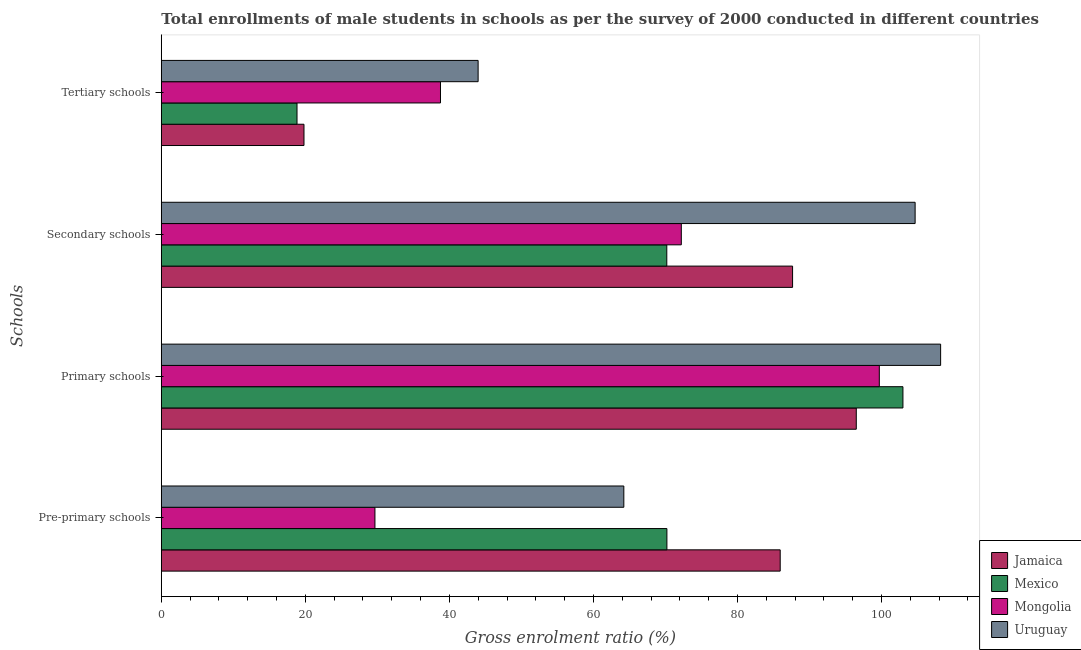How many different coloured bars are there?
Offer a very short reply. 4. How many groups of bars are there?
Provide a short and direct response. 4. Are the number of bars per tick equal to the number of legend labels?
Ensure brevity in your answer.  Yes. What is the label of the 2nd group of bars from the top?
Your answer should be very brief. Secondary schools. What is the gross enrolment ratio(male) in secondary schools in Jamaica?
Provide a succinct answer. 87.65. Across all countries, what is the maximum gross enrolment ratio(male) in pre-primary schools?
Give a very brief answer. 85.93. Across all countries, what is the minimum gross enrolment ratio(male) in tertiary schools?
Make the answer very short. 18.84. In which country was the gross enrolment ratio(male) in tertiary schools maximum?
Your answer should be compact. Uruguay. In which country was the gross enrolment ratio(male) in secondary schools minimum?
Offer a terse response. Mexico. What is the total gross enrolment ratio(male) in secondary schools in the graph?
Offer a terse response. 334.69. What is the difference between the gross enrolment ratio(male) in primary schools in Mexico and that in Mongolia?
Make the answer very short. 3.28. What is the difference between the gross enrolment ratio(male) in pre-primary schools in Mongolia and the gross enrolment ratio(male) in primary schools in Uruguay?
Provide a short and direct response. -78.54. What is the average gross enrolment ratio(male) in tertiary schools per country?
Your answer should be compact. 30.35. What is the difference between the gross enrolment ratio(male) in pre-primary schools and gross enrolment ratio(male) in secondary schools in Mexico?
Your answer should be compact. 0.01. What is the ratio of the gross enrolment ratio(male) in tertiary schools in Mexico to that in Uruguay?
Provide a succinct answer. 0.43. Is the difference between the gross enrolment ratio(male) in primary schools in Mongolia and Uruguay greater than the difference between the gross enrolment ratio(male) in tertiary schools in Mongolia and Uruguay?
Ensure brevity in your answer.  No. What is the difference between the highest and the second highest gross enrolment ratio(male) in tertiary schools?
Ensure brevity in your answer.  5.23. What is the difference between the highest and the lowest gross enrolment ratio(male) in pre-primary schools?
Make the answer very short. 56.27. In how many countries, is the gross enrolment ratio(male) in primary schools greater than the average gross enrolment ratio(male) in primary schools taken over all countries?
Provide a short and direct response. 2. What does the 1st bar from the top in Tertiary schools represents?
Your answer should be very brief. Uruguay. What does the 4th bar from the bottom in Pre-primary schools represents?
Your answer should be very brief. Uruguay. How many bars are there?
Your answer should be very brief. 16. What is the difference between two consecutive major ticks on the X-axis?
Provide a short and direct response. 20. Does the graph contain any zero values?
Offer a very short reply. No. Does the graph contain grids?
Provide a succinct answer. No. Where does the legend appear in the graph?
Your answer should be very brief. Bottom right. How many legend labels are there?
Keep it short and to the point. 4. How are the legend labels stacked?
Your answer should be very brief. Vertical. What is the title of the graph?
Your answer should be compact. Total enrollments of male students in schools as per the survey of 2000 conducted in different countries. Does "New Caledonia" appear as one of the legend labels in the graph?
Your response must be concise. No. What is the label or title of the X-axis?
Provide a succinct answer. Gross enrolment ratio (%). What is the label or title of the Y-axis?
Offer a terse response. Schools. What is the Gross enrolment ratio (%) of Jamaica in Pre-primary schools?
Your response must be concise. 85.93. What is the Gross enrolment ratio (%) in Mexico in Pre-primary schools?
Your answer should be very brief. 70.2. What is the Gross enrolment ratio (%) in Mongolia in Pre-primary schools?
Your response must be concise. 29.66. What is the Gross enrolment ratio (%) of Uruguay in Pre-primary schools?
Your answer should be very brief. 64.22. What is the Gross enrolment ratio (%) in Jamaica in Primary schools?
Your response must be concise. 96.49. What is the Gross enrolment ratio (%) in Mexico in Primary schools?
Give a very brief answer. 102.97. What is the Gross enrolment ratio (%) in Mongolia in Primary schools?
Offer a terse response. 99.69. What is the Gross enrolment ratio (%) of Uruguay in Primary schools?
Keep it short and to the point. 108.2. What is the Gross enrolment ratio (%) of Jamaica in Secondary schools?
Ensure brevity in your answer.  87.65. What is the Gross enrolment ratio (%) in Mexico in Secondary schools?
Ensure brevity in your answer.  70.18. What is the Gross enrolment ratio (%) in Mongolia in Secondary schools?
Ensure brevity in your answer.  72.2. What is the Gross enrolment ratio (%) of Uruguay in Secondary schools?
Ensure brevity in your answer.  104.66. What is the Gross enrolment ratio (%) of Jamaica in Tertiary schools?
Give a very brief answer. 19.81. What is the Gross enrolment ratio (%) in Mexico in Tertiary schools?
Ensure brevity in your answer.  18.84. What is the Gross enrolment ratio (%) of Mongolia in Tertiary schools?
Provide a succinct answer. 38.76. What is the Gross enrolment ratio (%) in Uruguay in Tertiary schools?
Ensure brevity in your answer.  43.99. Across all Schools, what is the maximum Gross enrolment ratio (%) of Jamaica?
Keep it short and to the point. 96.49. Across all Schools, what is the maximum Gross enrolment ratio (%) in Mexico?
Your answer should be compact. 102.97. Across all Schools, what is the maximum Gross enrolment ratio (%) in Mongolia?
Your answer should be very brief. 99.69. Across all Schools, what is the maximum Gross enrolment ratio (%) of Uruguay?
Offer a very short reply. 108.2. Across all Schools, what is the minimum Gross enrolment ratio (%) of Jamaica?
Keep it short and to the point. 19.81. Across all Schools, what is the minimum Gross enrolment ratio (%) of Mexico?
Make the answer very short. 18.84. Across all Schools, what is the minimum Gross enrolment ratio (%) of Mongolia?
Offer a terse response. 29.66. Across all Schools, what is the minimum Gross enrolment ratio (%) in Uruguay?
Offer a terse response. 43.99. What is the total Gross enrolment ratio (%) of Jamaica in the graph?
Your response must be concise. 289.88. What is the total Gross enrolment ratio (%) in Mexico in the graph?
Give a very brief answer. 262.19. What is the total Gross enrolment ratio (%) of Mongolia in the graph?
Your response must be concise. 240.31. What is the total Gross enrolment ratio (%) of Uruguay in the graph?
Offer a terse response. 321.07. What is the difference between the Gross enrolment ratio (%) of Jamaica in Pre-primary schools and that in Primary schools?
Your response must be concise. -10.56. What is the difference between the Gross enrolment ratio (%) in Mexico in Pre-primary schools and that in Primary schools?
Provide a succinct answer. -32.77. What is the difference between the Gross enrolment ratio (%) of Mongolia in Pre-primary schools and that in Primary schools?
Ensure brevity in your answer.  -70.03. What is the difference between the Gross enrolment ratio (%) in Uruguay in Pre-primary schools and that in Primary schools?
Your answer should be compact. -43.98. What is the difference between the Gross enrolment ratio (%) of Jamaica in Pre-primary schools and that in Secondary schools?
Keep it short and to the point. -1.72. What is the difference between the Gross enrolment ratio (%) of Mexico in Pre-primary schools and that in Secondary schools?
Keep it short and to the point. 0.01. What is the difference between the Gross enrolment ratio (%) of Mongolia in Pre-primary schools and that in Secondary schools?
Provide a succinct answer. -42.54. What is the difference between the Gross enrolment ratio (%) of Uruguay in Pre-primary schools and that in Secondary schools?
Your answer should be compact. -40.45. What is the difference between the Gross enrolment ratio (%) in Jamaica in Pre-primary schools and that in Tertiary schools?
Ensure brevity in your answer.  66.12. What is the difference between the Gross enrolment ratio (%) in Mexico in Pre-primary schools and that in Tertiary schools?
Ensure brevity in your answer.  51.36. What is the difference between the Gross enrolment ratio (%) of Mongolia in Pre-primary schools and that in Tertiary schools?
Give a very brief answer. -9.1. What is the difference between the Gross enrolment ratio (%) of Uruguay in Pre-primary schools and that in Tertiary schools?
Your answer should be compact. 20.23. What is the difference between the Gross enrolment ratio (%) in Jamaica in Primary schools and that in Secondary schools?
Your response must be concise. 8.85. What is the difference between the Gross enrolment ratio (%) in Mexico in Primary schools and that in Secondary schools?
Provide a short and direct response. 32.79. What is the difference between the Gross enrolment ratio (%) of Mongolia in Primary schools and that in Secondary schools?
Give a very brief answer. 27.49. What is the difference between the Gross enrolment ratio (%) in Uruguay in Primary schools and that in Secondary schools?
Your answer should be compact. 3.54. What is the difference between the Gross enrolment ratio (%) of Jamaica in Primary schools and that in Tertiary schools?
Offer a terse response. 76.68. What is the difference between the Gross enrolment ratio (%) in Mexico in Primary schools and that in Tertiary schools?
Ensure brevity in your answer.  84.13. What is the difference between the Gross enrolment ratio (%) in Mongolia in Primary schools and that in Tertiary schools?
Offer a very short reply. 60.93. What is the difference between the Gross enrolment ratio (%) of Uruguay in Primary schools and that in Tertiary schools?
Your response must be concise. 64.22. What is the difference between the Gross enrolment ratio (%) of Jamaica in Secondary schools and that in Tertiary schools?
Make the answer very short. 67.84. What is the difference between the Gross enrolment ratio (%) in Mexico in Secondary schools and that in Tertiary schools?
Offer a very short reply. 51.34. What is the difference between the Gross enrolment ratio (%) in Mongolia in Secondary schools and that in Tertiary schools?
Your answer should be compact. 33.44. What is the difference between the Gross enrolment ratio (%) of Uruguay in Secondary schools and that in Tertiary schools?
Your answer should be compact. 60.68. What is the difference between the Gross enrolment ratio (%) of Jamaica in Pre-primary schools and the Gross enrolment ratio (%) of Mexico in Primary schools?
Offer a terse response. -17.04. What is the difference between the Gross enrolment ratio (%) in Jamaica in Pre-primary schools and the Gross enrolment ratio (%) in Mongolia in Primary schools?
Provide a short and direct response. -13.76. What is the difference between the Gross enrolment ratio (%) in Jamaica in Pre-primary schools and the Gross enrolment ratio (%) in Uruguay in Primary schools?
Keep it short and to the point. -22.27. What is the difference between the Gross enrolment ratio (%) of Mexico in Pre-primary schools and the Gross enrolment ratio (%) of Mongolia in Primary schools?
Your answer should be compact. -29.49. What is the difference between the Gross enrolment ratio (%) of Mexico in Pre-primary schools and the Gross enrolment ratio (%) of Uruguay in Primary schools?
Give a very brief answer. -38. What is the difference between the Gross enrolment ratio (%) of Mongolia in Pre-primary schools and the Gross enrolment ratio (%) of Uruguay in Primary schools?
Provide a succinct answer. -78.54. What is the difference between the Gross enrolment ratio (%) of Jamaica in Pre-primary schools and the Gross enrolment ratio (%) of Mexico in Secondary schools?
Make the answer very short. 15.75. What is the difference between the Gross enrolment ratio (%) of Jamaica in Pre-primary schools and the Gross enrolment ratio (%) of Mongolia in Secondary schools?
Ensure brevity in your answer.  13.73. What is the difference between the Gross enrolment ratio (%) in Jamaica in Pre-primary schools and the Gross enrolment ratio (%) in Uruguay in Secondary schools?
Your response must be concise. -18.73. What is the difference between the Gross enrolment ratio (%) in Mexico in Pre-primary schools and the Gross enrolment ratio (%) in Mongolia in Secondary schools?
Give a very brief answer. -2. What is the difference between the Gross enrolment ratio (%) in Mexico in Pre-primary schools and the Gross enrolment ratio (%) in Uruguay in Secondary schools?
Provide a succinct answer. -34.46. What is the difference between the Gross enrolment ratio (%) of Mongolia in Pre-primary schools and the Gross enrolment ratio (%) of Uruguay in Secondary schools?
Offer a terse response. -75. What is the difference between the Gross enrolment ratio (%) of Jamaica in Pre-primary schools and the Gross enrolment ratio (%) of Mexico in Tertiary schools?
Your answer should be very brief. 67.09. What is the difference between the Gross enrolment ratio (%) in Jamaica in Pre-primary schools and the Gross enrolment ratio (%) in Mongolia in Tertiary schools?
Provide a succinct answer. 47.17. What is the difference between the Gross enrolment ratio (%) of Jamaica in Pre-primary schools and the Gross enrolment ratio (%) of Uruguay in Tertiary schools?
Give a very brief answer. 41.94. What is the difference between the Gross enrolment ratio (%) in Mexico in Pre-primary schools and the Gross enrolment ratio (%) in Mongolia in Tertiary schools?
Keep it short and to the point. 31.44. What is the difference between the Gross enrolment ratio (%) of Mexico in Pre-primary schools and the Gross enrolment ratio (%) of Uruguay in Tertiary schools?
Your answer should be very brief. 26.21. What is the difference between the Gross enrolment ratio (%) of Mongolia in Pre-primary schools and the Gross enrolment ratio (%) of Uruguay in Tertiary schools?
Provide a short and direct response. -14.33. What is the difference between the Gross enrolment ratio (%) in Jamaica in Primary schools and the Gross enrolment ratio (%) in Mexico in Secondary schools?
Make the answer very short. 26.31. What is the difference between the Gross enrolment ratio (%) in Jamaica in Primary schools and the Gross enrolment ratio (%) in Mongolia in Secondary schools?
Provide a succinct answer. 24.29. What is the difference between the Gross enrolment ratio (%) in Jamaica in Primary schools and the Gross enrolment ratio (%) in Uruguay in Secondary schools?
Provide a succinct answer. -8.17. What is the difference between the Gross enrolment ratio (%) in Mexico in Primary schools and the Gross enrolment ratio (%) in Mongolia in Secondary schools?
Give a very brief answer. 30.77. What is the difference between the Gross enrolment ratio (%) of Mexico in Primary schools and the Gross enrolment ratio (%) of Uruguay in Secondary schools?
Give a very brief answer. -1.69. What is the difference between the Gross enrolment ratio (%) of Mongolia in Primary schools and the Gross enrolment ratio (%) of Uruguay in Secondary schools?
Keep it short and to the point. -4.97. What is the difference between the Gross enrolment ratio (%) of Jamaica in Primary schools and the Gross enrolment ratio (%) of Mexico in Tertiary schools?
Make the answer very short. 77.65. What is the difference between the Gross enrolment ratio (%) of Jamaica in Primary schools and the Gross enrolment ratio (%) of Mongolia in Tertiary schools?
Your response must be concise. 57.73. What is the difference between the Gross enrolment ratio (%) of Jamaica in Primary schools and the Gross enrolment ratio (%) of Uruguay in Tertiary schools?
Offer a very short reply. 52.51. What is the difference between the Gross enrolment ratio (%) of Mexico in Primary schools and the Gross enrolment ratio (%) of Mongolia in Tertiary schools?
Ensure brevity in your answer.  64.21. What is the difference between the Gross enrolment ratio (%) in Mexico in Primary schools and the Gross enrolment ratio (%) in Uruguay in Tertiary schools?
Keep it short and to the point. 58.98. What is the difference between the Gross enrolment ratio (%) in Mongolia in Primary schools and the Gross enrolment ratio (%) in Uruguay in Tertiary schools?
Give a very brief answer. 55.7. What is the difference between the Gross enrolment ratio (%) of Jamaica in Secondary schools and the Gross enrolment ratio (%) of Mexico in Tertiary schools?
Provide a succinct answer. 68.81. What is the difference between the Gross enrolment ratio (%) of Jamaica in Secondary schools and the Gross enrolment ratio (%) of Mongolia in Tertiary schools?
Offer a very short reply. 48.89. What is the difference between the Gross enrolment ratio (%) of Jamaica in Secondary schools and the Gross enrolment ratio (%) of Uruguay in Tertiary schools?
Your response must be concise. 43.66. What is the difference between the Gross enrolment ratio (%) in Mexico in Secondary schools and the Gross enrolment ratio (%) in Mongolia in Tertiary schools?
Make the answer very short. 31.42. What is the difference between the Gross enrolment ratio (%) in Mexico in Secondary schools and the Gross enrolment ratio (%) in Uruguay in Tertiary schools?
Provide a short and direct response. 26.2. What is the difference between the Gross enrolment ratio (%) of Mongolia in Secondary schools and the Gross enrolment ratio (%) of Uruguay in Tertiary schools?
Provide a short and direct response. 28.21. What is the average Gross enrolment ratio (%) of Jamaica per Schools?
Make the answer very short. 72.47. What is the average Gross enrolment ratio (%) of Mexico per Schools?
Offer a very short reply. 65.55. What is the average Gross enrolment ratio (%) of Mongolia per Schools?
Keep it short and to the point. 60.08. What is the average Gross enrolment ratio (%) in Uruguay per Schools?
Keep it short and to the point. 80.27. What is the difference between the Gross enrolment ratio (%) in Jamaica and Gross enrolment ratio (%) in Mexico in Pre-primary schools?
Provide a succinct answer. 15.73. What is the difference between the Gross enrolment ratio (%) of Jamaica and Gross enrolment ratio (%) of Mongolia in Pre-primary schools?
Keep it short and to the point. 56.27. What is the difference between the Gross enrolment ratio (%) of Jamaica and Gross enrolment ratio (%) of Uruguay in Pre-primary schools?
Keep it short and to the point. 21.71. What is the difference between the Gross enrolment ratio (%) in Mexico and Gross enrolment ratio (%) in Mongolia in Pre-primary schools?
Provide a short and direct response. 40.54. What is the difference between the Gross enrolment ratio (%) of Mexico and Gross enrolment ratio (%) of Uruguay in Pre-primary schools?
Your response must be concise. 5.98. What is the difference between the Gross enrolment ratio (%) of Mongolia and Gross enrolment ratio (%) of Uruguay in Pre-primary schools?
Provide a succinct answer. -34.56. What is the difference between the Gross enrolment ratio (%) in Jamaica and Gross enrolment ratio (%) in Mexico in Primary schools?
Keep it short and to the point. -6.48. What is the difference between the Gross enrolment ratio (%) of Jamaica and Gross enrolment ratio (%) of Mongolia in Primary schools?
Your answer should be compact. -3.2. What is the difference between the Gross enrolment ratio (%) in Jamaica and Gross enrolment ratio (%) in Uruguay in Primary schools?
Your response must be concise. -11.71. What is the difference between the Gross enrolment ratio (%) of Mexico and Gross enrolment ratio (%) of Mongolia in Primary schools?
Your response must be concise. 3.28. What is the difference between the Gross enrolment ratio (%) in Mexico and Gross enrolment ratio (%) in Uruguay in Primary schools?
Your answer should be very brief. -5.23. What is the difference between the Gross enrolment ratio (%) in Mongolia and Gross enrolment ratio (%) in Uruguay in Primary schools?
Ensure brevity in your answer.  -8.51. What is the difference between the Gross enrolment ratio (%) of Jamaica and Gross enrolment ratio (%) of Mexico in Secondary schools?
Your answer should be compact. 17.46. What is the difference between the Gross enrolment ratio (%) of Jamaica and Gross enrolment ratio (%) of Mongolia in Secondary schools?
Your answer should be compact. 15.45. What is the difference between the Gross enrolment ratio (%) of Jamaica and Gross enrolment ratio (%) of Uruguay in Secondary schools?
Give a very brief answer. -17.01. What is the difference between the Gross enrolment ratio (%) in Mexico and Gross enrolment ratio (%) in Mongolia in Secondary schools?
Give a very brief answer. -2.01. What is the difference between the Gross enrolment ratio (%) of Mexico and Gross enrolment ratio (%) of Uruguay in Secondary schools?
Ensure brevity in your answer.  -34.48. What is the difference between the Gross enrolment ratio (%) in Mongolia and Gross enrolment ratio (%) in Uruguay in Secondary schools?
Offer a terse response. -32.46. What is the difference between the Gross enrolment ratio (%) in Jamaica and Gross enrolment ratio (%) in Mexico in Tertiary schools?
Ensure brevity in your answer.  0.97. What is the difference between the Gross enrolment ratio (%) of Jamaica and Gross enrolment ratio (%) of Mongolia in Tertiary schools?
Offer a very short reply. -18.95. What is the difference between the Gross enrolment ratio (%) of Jamaica and Gross enrolment ratio (%) of Uruguay in Tertiary schools?
Offer a terse response. -24.18. What is the difference between the Gross enrolment ratio (%) of Mexico and Gross enrolment ratio (%) of Mongolia in Tertiary schools?
Your response must be concise. -19.92. What is the difference between the Gross enrolment ratio (%) in Mexico and Gross enrolment ratio (%) in Uruguay in Tertiary schools?
Offer a terse response. -25.15. What is the difference between the Gross enrolment ratio (%) in Mongolia and Gross enrolment ratio (%) in Uruguay in Tertiary schools?
Provide a short and direct response. -5.23. What is the ratio of the Gross enrolment ratio (%) of Jamaica in Pre-primary schools to that in Primary schools?
Provide a short and direct response. 0.89. What is the ratio of the Gross enrolment ratio (%) in Mexico in Pre-primary schools to that in Primary schools?
Your response must be concise. 0.68. What is the ratio of the Gross enrolment ratio (%) in Mongolia in Pre-primary schools to that in Primary schools?
Provide a short and direct response. 0.3. What is the ratio of the Gross enrolment ratio (%) of Uruguay in Pre-primary schools to that in Primary schools?
Ensure brevity in your answer.  0.59. What is the ratio of the Gross enrolment ratio (%) of Jamaica in Pre-primary schools to that in Secondary schools?
Give a very brief answer. 0.98. What is the ratio of the Gross enrolment ratio (%) of Mexico in Pre-primary schools to that in Secondary schools?
Make the answer very short. 1. What is the ratio of the Gross enrolment ratio (%) in Mongolia in Pre-primary schools to that in Secondary schools?
Offer a very short reply. 0.41. What is the ratio of the Gross enrolment ratio (%) of Uruguay in Pre-primary schools to that in Secondary schools?
Ensure brevity in your answer.  0.61. What is the ratio of the Gross enrolment ratio (%) in Jamaica in Pre-primary schools to that in Tertiary schools?
Give a very brief answer. 4.34. What is the ratio of the Gross enrolment ratio (%) in Mexico in Pre-primary schools to that in Tertiary schools?
Your answer should be compact. 3.73. What is the ratio of the Gross enrolment ratio (%) of Mongolia in Pre-primary schools to that in Tertiary schools?
Your answer should be very brief. 0.77. What is the ratio of the Gross enrolment ratio (%) of Uruguay in Pre-primary schools to that in Tertiary schools?
Provide a succinct answer. 1.46. What is the ratio of the Gross enrolment ratio (%) of Jamaica in Primary schools to that in Secondary schools?
Provide a short and direct response. 1.1. What is the ratio of the Gross enrolment ratio (%) of Mexico in Primary schools to that in Secondary schools?
Your answer should be very brief. 1.47. What is the ratio of the Gross enrolment ratio (%) in Mongolia in Primary schools to that in Secondary schools?
Provide a succinct answer. 1.38. What is the ratio of the Gross enrolment ratio (%) of Uruguay in Primary schools to that in Secondary schools?
Provide a short and direct response. 1.03. What is the ratio of the Gross enrolment ratio (%) of Jamaica in Primary schools to that in Tertiary schools?
Offer a very short reply. 4.87. What is the ratio of the Gross enrolment ratio (%) in Mexico in Primary schools to that in Tertiary schools?
Make the answer very short. 5.47. What is the ratio of the Gross enrolment ratio (%) of Mongolia in Primary schools to that in Tertiary schools?
Give a very brief answer. 2.57. What is the ratio of the Gross enrolment ratio (%) in Uruguay in Primary schools to that in Tertiary schools?
Make the answer very short. 2.46. What is the ratio of the Gross enrolment ratio (%) of Jamaica in Secondary schools to that in Tertiary schools?
Provide a short and direct response. 4.42. What is the ratio of the Gross enrolment ratio (%) of Mexico in Secondary schools to that in Tertiary schools?
Your answer should be very brief. 3.73. What is the ratio of the Gross enrolment ratio (%) in Mongolia in Secondary schools to that in Tertiary schools?
Keep it short and to the point. 1.86. What is the ratio of the Gross enrolment ratio (%) of Uruguay in Secondary schools to that in Tertiary schools?
Keep it short and to the point. 2.38. What is the difference between the highest and the second highest Gross enrolment ratio (%) of Jamaica?
Offer a very short reply. 8.85. What is the difference between the highest and the second highest Gross enrolment ratio (%) in Mexico?
Make the answer very short. 32.77. What is the difference between the highest and the second highest Gross enrolment ratio (%) in Mongolia?
Offer a terse response. 27.49. What is the difference between the highest and the second highest Gross enrolment ratio (%) in Uruguay?
Keep it short and to the point. 3.54. What is the difference between the highest and the lowest Gross enrolment ratio (%) of Jamaica?
Provide a succinct answer. 76.68. What is the difference between the highest and the lowest Gross enrolment ratio (%) of Mexico?
Your response must be concise. 84.13. What is the difference between the highest and the lowest Gross enrolment ratio (%) in Mongolia?
Your answer should be compact. 70.03. What is the difference between the highest and the lowest Gross enrolment ratio (%) of Uruguay?
Give a very brief answer. 64.22. 